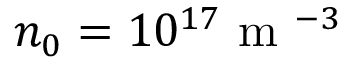<formula> <loc_0><loc_0><loc_500><loc_500>n _ { 0 } = 1 0 ^ { 1 7 } m ^ { - 3 }</formula> 